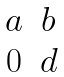Convert formula to latex. <formula><loc_0><loc_0><loc_500><loc_500>\begin{matrix} a & b \\ 0 & d \\ \end{matrix}</formula> 